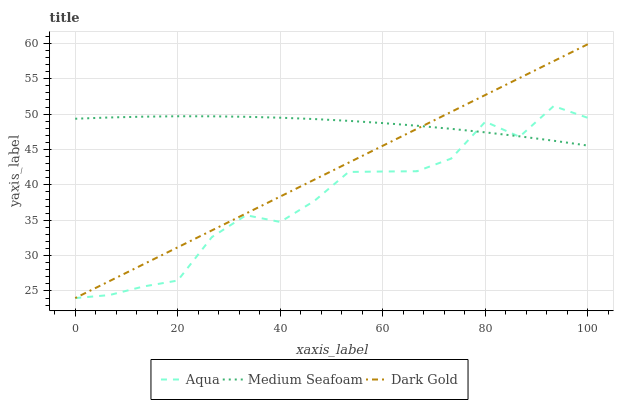Does Aqua have the minimum area under the curve?
Answer yes or no. Yes. Does Medium Seafoam have the maximum area under the curve?
Answer yes or no. Yes. Does Dark Gold have the minimum area under the curve?
Answer yes or no. No. Does Dark Gold have the maximum area under the curve?
Answer yes or no. No. Is Dark Gold the smoothest?
Answer yes or no. Yes. Is Aqua the roughest?
Answer yes or no. Yes. Is Medium Seafoam the smoothest?
Answer yes or no. No. Is Medium Seafoam the roughest?
Answer yes or no. No. Does Medium Seafoam have the lowest value?
Answer yes or no. No. Does Dark Gold have the highest value?
Answer yes or no. Yes. Does Medium Seafoam have the highest value?
Answer yes or no. No. Does Medium Seafoam intersect Aqua?
Answer yes or no. Yes. Is Medium Seafoam less than Aqua?
Answer yes or no. No. Is Medium Seafoam greater than Aqua?
Answer yes or no. No. 